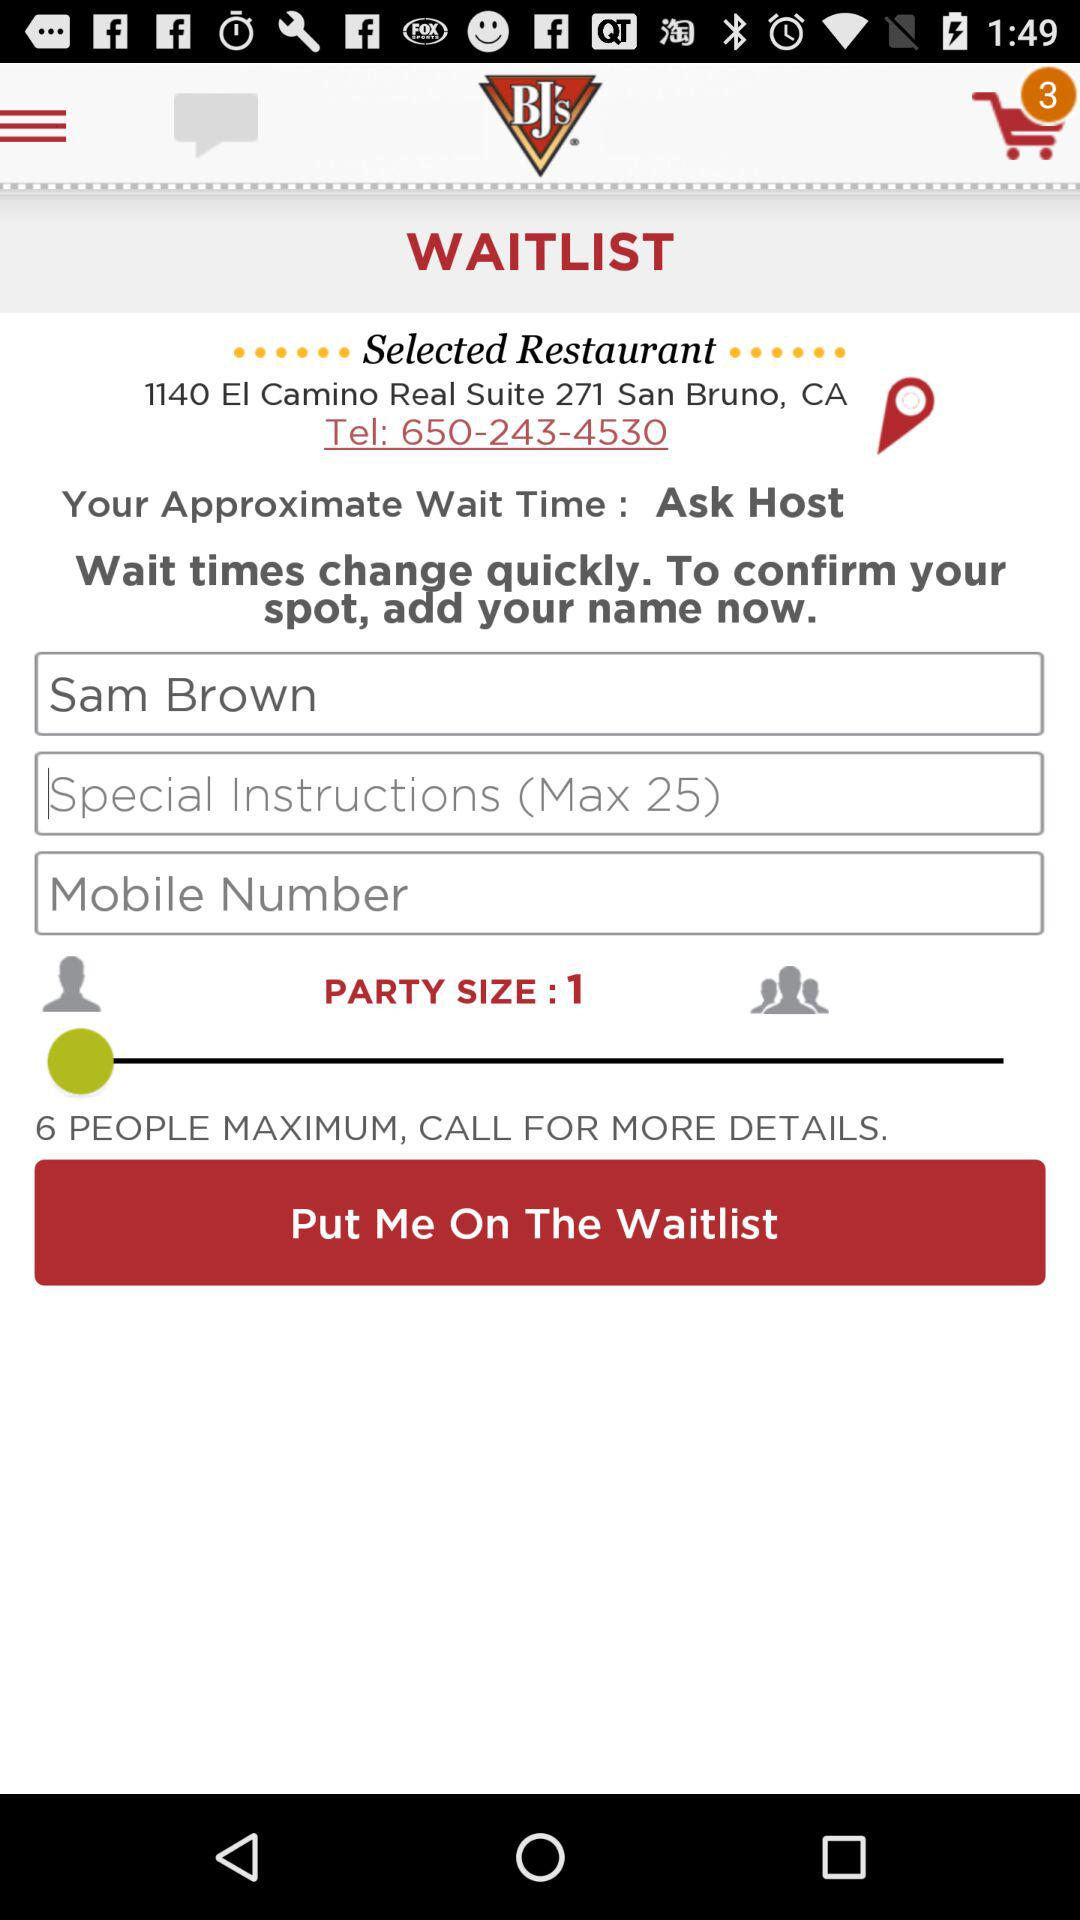How many more people can be added to the party?
Answer the question using a single word or phrase. 5 